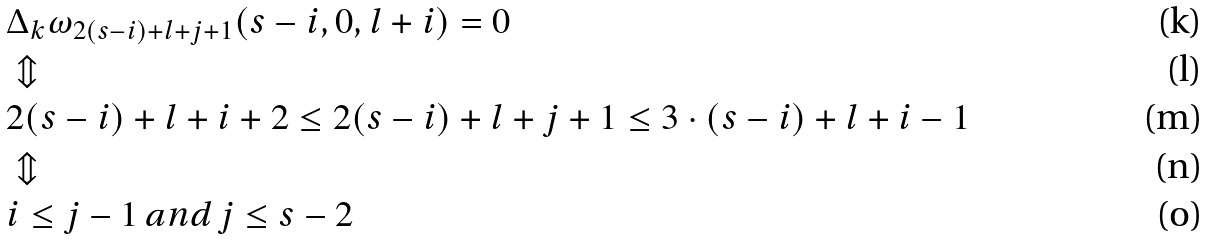Convert formula to latex. <formula><loc_0><loc_0><loc_500><loc_500>& \Delta _ { k } \omega _ { 2 ( s - i ) + l + j + 1 } ( s - i , 0 , l + i ) = 0 \\ & \Updownarrow \\ & 2 ( s - i ) + l + i + 2 \leq 2 ( s - i ) + l + j + 1 \leq 3 \cdot ( s - i ) + l + i - 1 \\ & \Updownarrow \\ & i \leq j - 1 \, a n d \, j \leq s - 2</formula> 